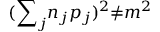<formula> <loc_0><loc_0><loc_500><loc_500>( { { \sum } _ { j } n _ { j } p _ { j } } ) ^ { 2 } { \neq } m ^ { 2 }</formula> 